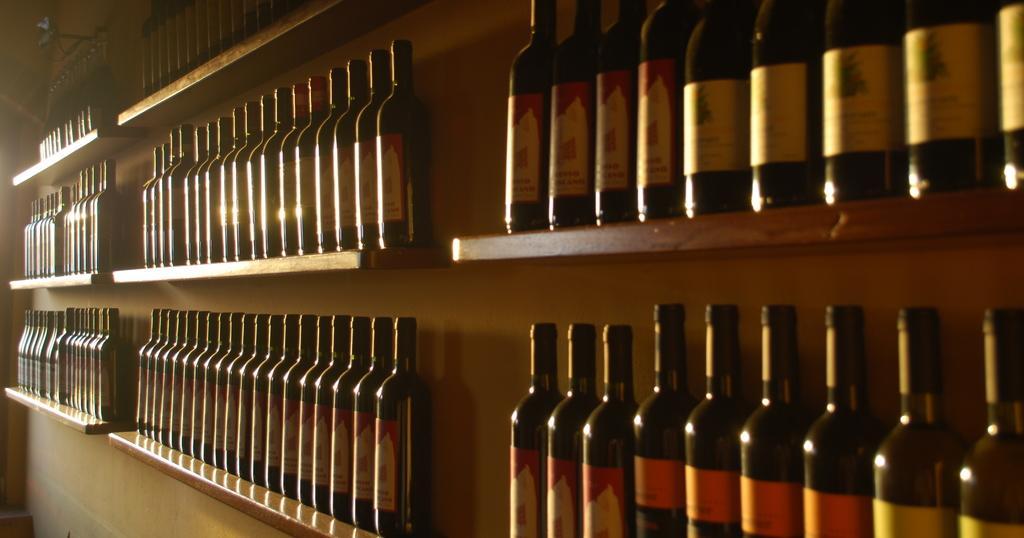How would you summarize this image in a sentence or two? In this image there are group of bottles with the lid and a label arranged in an order in placed in a wooden rack. 